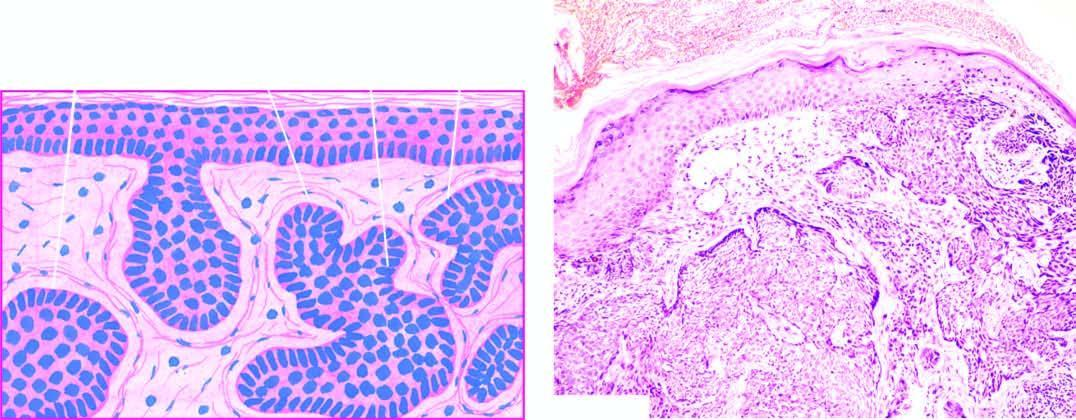what are the masses of tumour cells separated from?
Answer the question using a single word or phrase. Dermal collagen by a space called shrinkage artefact 